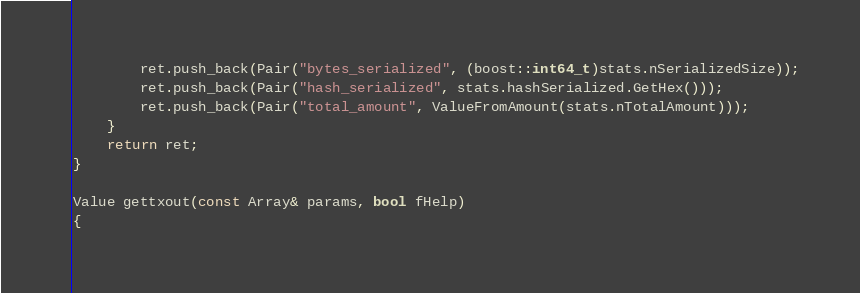Convert code to text. <code><loc_0><loc_0><loc_500><loc_500><_C++_>        ret.push_back(Pair("bytes_serialized", (boost::int64_t)stats.nSerializedSize));
        ret.push_back(Pair("hash_serialized", stats.hashSerialized.GetHex()));
        ret.push_back(Pair("total_amount", ValueFromAmount(stats.nTotalAmount)));
    }
    return ret;
}

Value gettxout(const Array& params, bool fHelp)
{</code> 